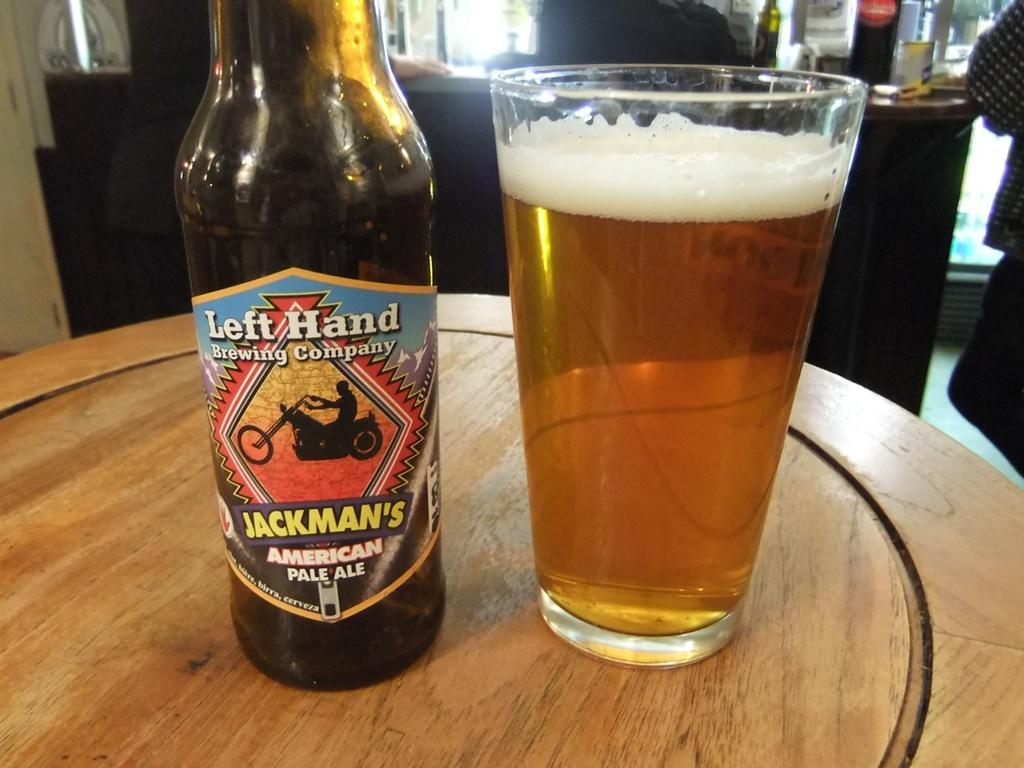<image>
Summarize the visual content of the image. a bottle of jackman's american pale ale next to a full glass 